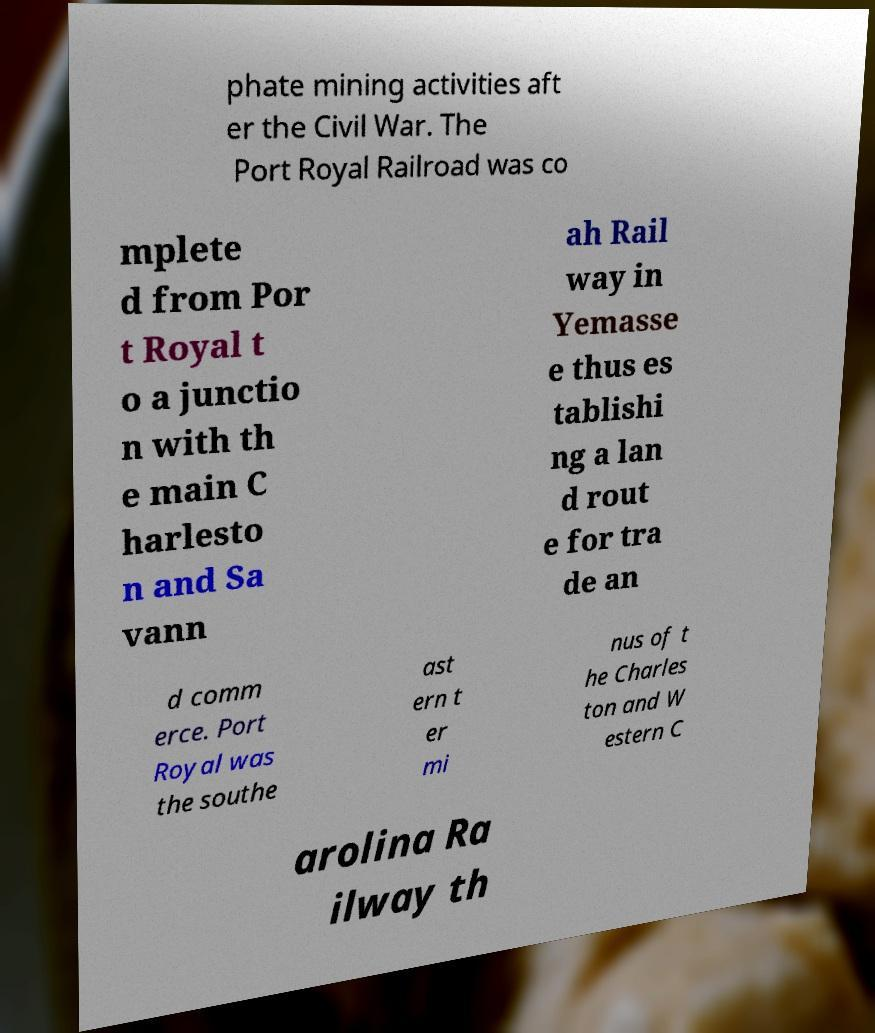What messages or text are displayed in this image? I need them in a readable, typed format. phate mining activities aft er the Civil War. The Port Royal Railroad was co mplete d from Por t Royal t o a junctio n with th e main C harlesto n and Sa vann ah Rail way in Yemasse e thus es tablishi ng a lan d rout e for tra de an d comm erce. Port Royal was the southe ast ern t er mi nus of t he Charles ton and W estern C arolina Ra ilway th 